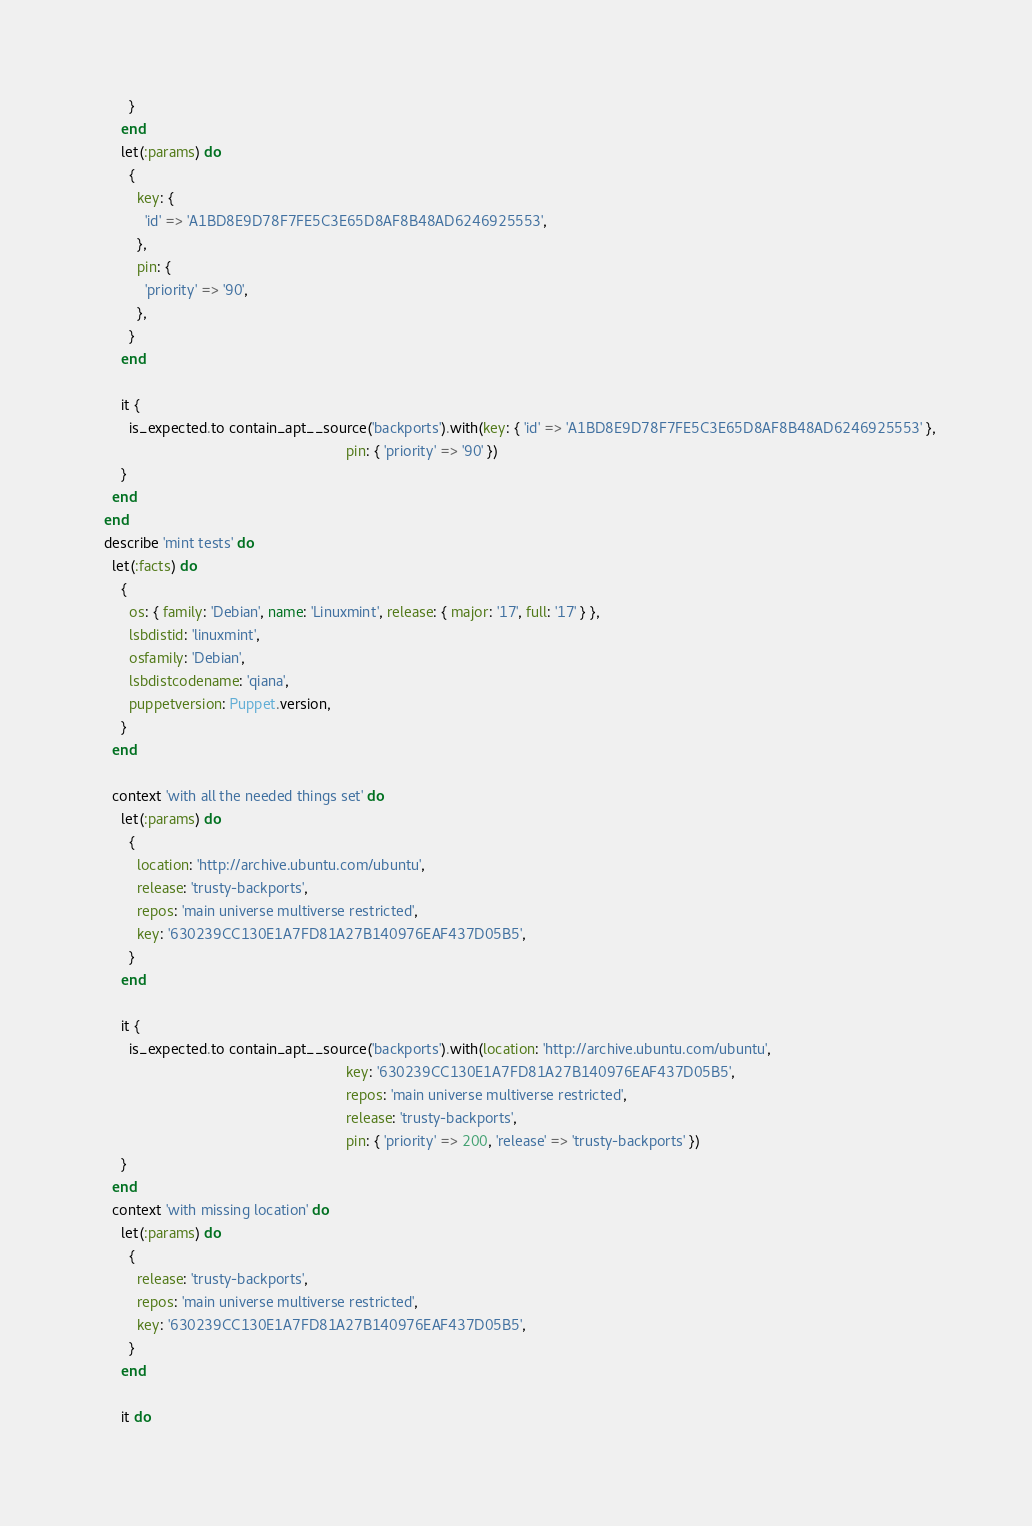<code> <loc_0><loc_0><loc_500><loc_500><_Ruby_>        }
      end
      let(:params) do
        {
          key: {
            'id' => 'A1BD8E9D78F7FE5C3E65D8AF8B48AD6246925553',
          },
          pin: {
            'priority' => '90',
          },
        }
      end

      it {
        is_expected.to contain_apt__source('backports').with(key: { 'id' => 'A1BD8E9D78F7FE5C3E65D8AF8B48AD6246925553' },
                                                             pin: { 'priority' => '90' })
      }
    end
  end
  describe 'mint tests' do
    let(:facts) do
      {
        os: { family: 'Debian', name: 'Linuxmint', release: { major: '17', full: '17' } },
        lsbdistid: 'linuxmint',
        osfamily: 'Debian',
        lsbdistcodename: 'qiana',
        puppetversion: Puppet.version,
      }
    end

    context 'with all the needed things set' do
      let(:params) do
        {
          location: 'http://archive.ubuntu.com/ubuntu',
          release: 'trusty-backports',
          repos: 'main universe multiverse restricted',
          key: '630239CC130E1A7FD81A27B140976EAF437D05B5',
        }
      end

      it {
        is_expected.to contain_apt__source('backports').with(location: 'http://archive.ubuntu.com/ubuntu',
                                                             key: '630239CC130E1A7FD81A27B140976EAF437D05B5',
                                                             repos: 'main universe multiverse restricted',
                                                             release: 'trusty-backports',
                                                             pin: { 'priority' => 200, 'release' => 'trusty-backports' })
      }
    end
    context 'with missing location' do
      let(:params) do
        {
          release: 'trusty-backports',
          repos: 'main universe multiverse restricted',
          key: '630239CC130E1A7FD81A27B140976EAF437D05B5',
        }
      end

      it do</code> 